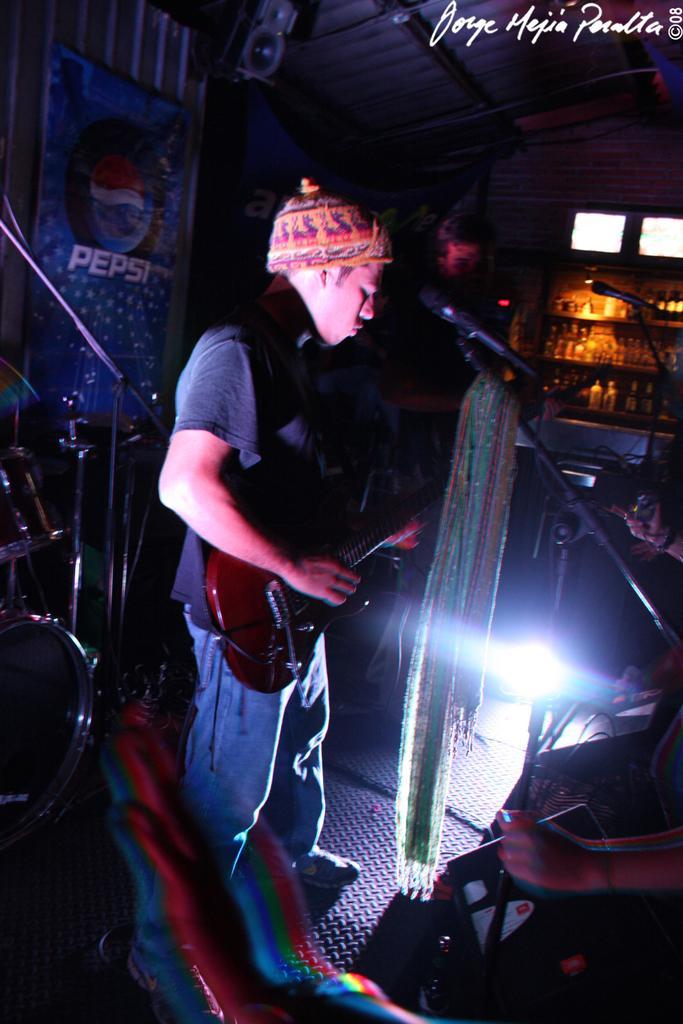Could you give a brief overview of what you see in this image? A man is standing and playing the guitar. He wore t-shirt, cap, on the right side there is a microphone. 